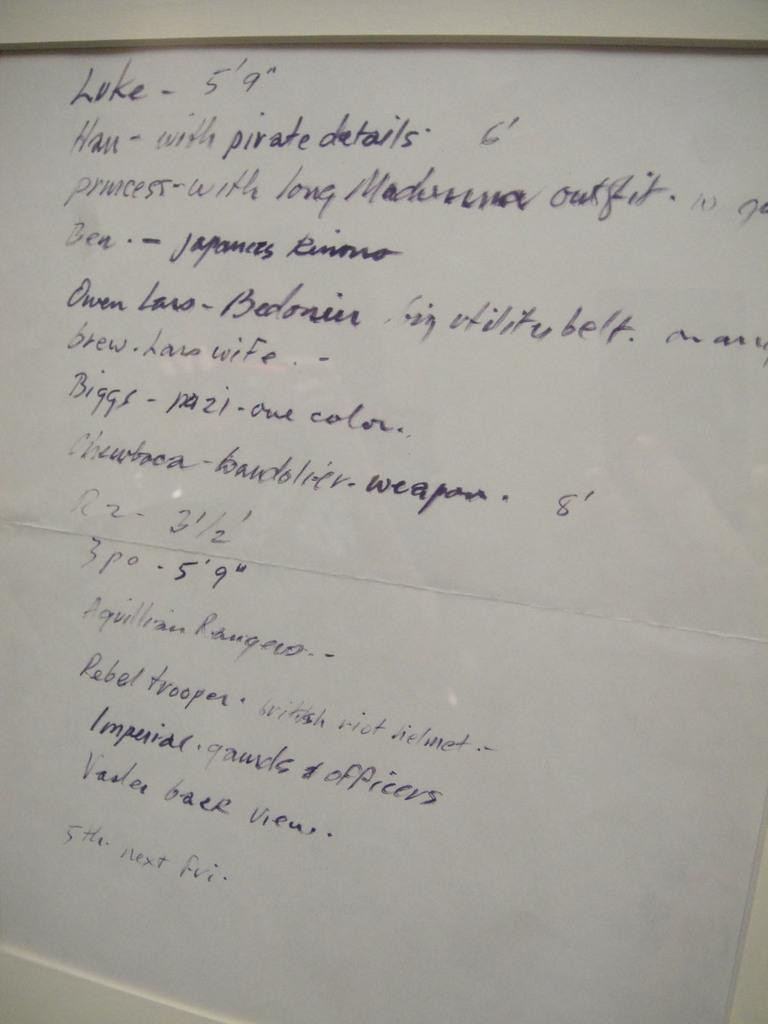<image>
Offer a succinct explanation of the picture presented. Handwritten text on a rectangular sheet of paper that includes some details containing height. 